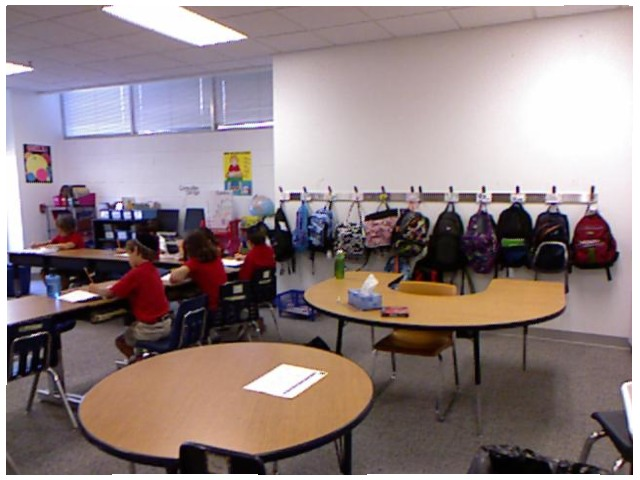<image>
Is the backpack on the wall? Yes. Looking at the image, I can see the backpack is positioned on top of the wall, with the wall providing support. Is there a box on the table? No. The box is not positioned on the table. They may be near each other, but the box is not supported by or resting on top of the table. Is the student on the chair? No. The student is not positioned on the chair. They may be near each other, but the student is not supported by or resting on top of the chair. Where is the bag in relation to the table? Is it behind the table? Yes. From this viewpoint, the bag is positioned behind the table, with the table partially or fully occluding the bag. 